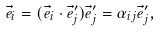<formula> <loc_0><loc_0><loc_500><loc_500>\vec { e } _ { i } = ( \vec { e } _ { i } \cdot \vec { e } _ { j } ^ { \prime } ) \vec { e } _ { j } ^ { \prime } = \alpha _ { i j } \vec { e } _ { j } ^ { \prime } ,</formula> 